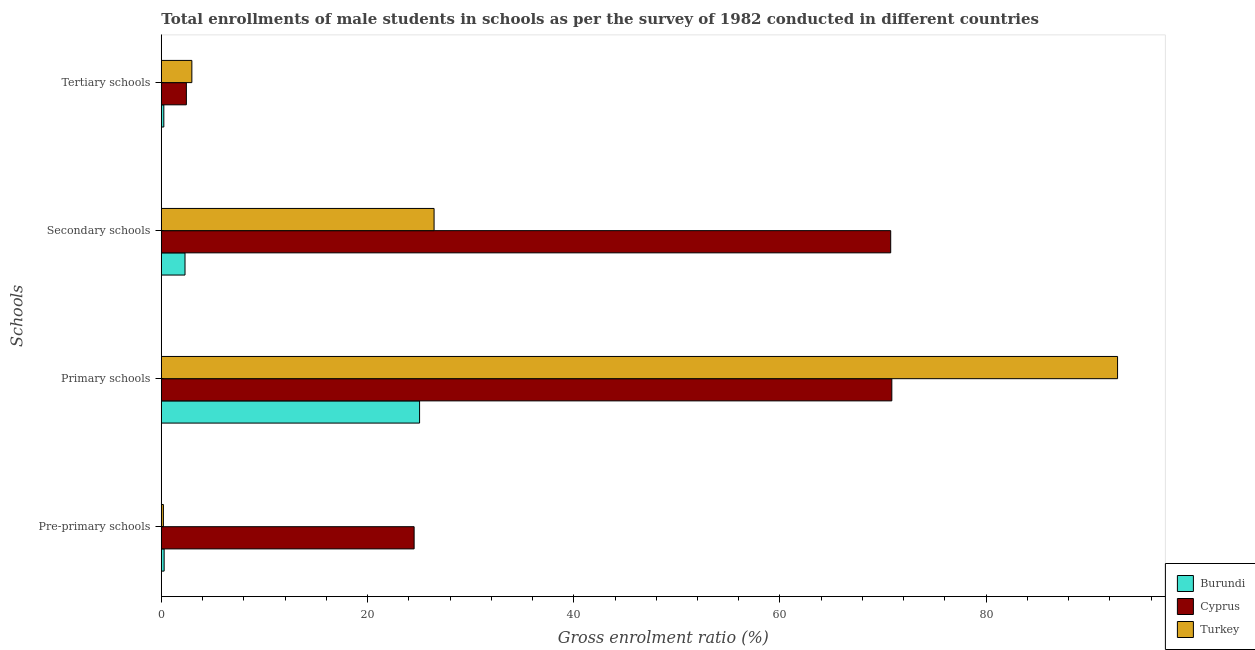Are the number of bars per tick equal to the number of legend labels?
Give a very brief answer. Yes. Are the number of bars on each tick of the Y-axis equal?
Provide a short and direct response. Yes. How many bars are there on the 1st tick from the top?
Ensure brevity in your answer.  3. What is the label of the 2nd group of bars from the top?
Your answer should be compact. Secondary schools. What is the gross enrolment ratio(male) in tertiary schools in Burundi?
Your answer should be very brief. 0.24. Across all countries, what is the maximum gross enrolment ratio(male) in primary schools?
Provide a succinct answer. 92.74. Across all countries, what is the minimum gross enrolment ratio(male) in primary schools?
Ensure brevity in your answer.  25.05. In which country was the gross enrolment ratio(male) in pre-primary schools minimum?
Offer a terse response. Turkey. What is the total gross enrolment ratio(male) in secondary schools in the graph?
Provide a short and direct response. 99.49. What is the difference between the gross enrolment ratio(male) in tertiary schools in Turkey and that in Cyprus?
Give a very brief answer. 0.53. What is the difference between the gross enrolment ratio(male) in tertiary schools in Cyprus and the gross enrolment ratio(male) in primary schools in Turkey?
Make the answer very short. -90.31. What is the average gross enrolment ratio(male) in primary schools per country?
Keep it short and to the point. 62.88. What is the difference between the gross enrolment ratio(male) in secondary schools and gross enrolment ratio(male) in tertiary schools in Cyprus?
Your answer should be compact. 68.31. What is the ratio of the gross enrolment ratio(male) in pre-primary schools in Turkey to that in Cyprus?
Keep it short and to the point. 0.01. Is the gross enrolment ratio(male) in secondary schools in Cyprus less than that in Burundi?
Give a very brief answer. No. What is the difference between the highest and the second highest gross enrolment ratio(male) in secondary schools?
Provide a succinct answer. 44.29. What is the difference between the highest and the lowest gross enrolment ratio(male) in secondary schools?
Provide a succinct answer. 68.44. In how many countries, is the gross enrolment ratio(male) in tertiary schools greater than the average gross enrolment ratio(male) in tertiary schools taken over all countries?
Make the answer very short. 2. Is the sum of the gross enrolment ratio(male) in primary schools in Turkey and Burundi greater than the maximum gross enrolment ratio(male) in tertiary schools across all countries?
Your answer should be compact. Yes. Is it the case that in every country, the sum of the gross enrolment ratio(male) in primary schools and gross enrolment ratio(male) in tertiary schools is greater than the sum of gross enrolment ratio(male) in pre-primary schools and gross enrolment ratio(male) in secondary schools?
Your answer should be very brief. Yes. What does the 3rd bar from the top in Tertiary schools represents?
Offer a terse response. Burundi. What does the 1st bar from the bottom in Tertiary schools represents?
Provide a short and direct response. Burundi. Is it the case that in every country, the sum of the gross enrolment ratio(male) in pre-primary schools and gross enrolment ratio(male) in primary schools is greater than the gross enrolment ratio(male) in secondary schools?
Offer a terse response. Yes. How many bars are there?
Your answer should be compact. 12. Are all the bars in the graph horizontal?
Keep it short and to the point. Yes. What is the difference between two consecutive major ticks on the X-axis?
Offer a terse response. 20. Does the graph contain any zero values?
Your answer should be compact. No. Does the graph contain grids?
Your response must be concise. No. Where does the legend appear in the graph?
Keep it short and to the point. Bottom right. How many legend labels are there?
Make the answer very short. 3. What is the title of the graph?
Provide a succinct answer. Total enrollments of male students in schools as per the survey of 1982 conducted in different countries. What is the label or title of the Y-axis?
Your answer should be very brief. Schools. What is the Gross enrolment ratio (%) in Burundi in Pre-primary schools?
Keep it short and to the point. 0.27. What is the Gross enrolment ratio (%) of Cyprus in Pre-primary schools?
Make the answer very short. 24.52. What is the Gross enrolment ratio (%) in Turkey in Pre-primary schools?
Your response must be concise. 0.2. What is the Gross enrolment ratio (%) of Burundi in Primary schools?
Your response must be concise. 25.05. What is the Gross enrolment ratio (%) in Cyprus in Primary schools?
Provide a short and direct response. 70.85. What is the Gross enrolment ratio (%) of Turkey in Primary schools?
Offer a terse response. 92.74. What is the Gross enrolment ratio (%) of Burundi in Secondary schools?
Ensure brevity in your answer.  2.3. What is the Gross enrolment ratio (%) of Cyprus in Secondary schools?
Your answer should be very brief. 70.74. What is the Gross enrolment ratio (%) of Turkey in Secondary schools?
Offer a terse response. 26.45. What is the Gross enrolment ratio (%) in Burundi in Tertiary schools?
Offer a very short reply. 0.24. What is the Gross enrolment ratio (%) of Cyprus in Tertiary schools?
Provide a succinct answer. 2.43. What is the Gross enrolment ratio (%) of Turkey in Tertiary schools?
Offer a very short reply. 2.96. Across all Schools, what is the maximum Gross enrolment ratio (%) of Burundi?
Your answer should be compact. 25.05. Across all Schools, what is the maximum Gross enrolment ratio (%) in Cyprus?
Your answer should be compact. 70.85. Across all Schools, what is the maximum Gross enrolment ratio (%) of Turkey?
Make the answer very short. 92.74. Across all Schools, what is the minimum Gross enrolment ratio (%) in Burundi?
Offer a terse response. 0.24. Across all Schools, what is the minimum Gross enrolment ratio (%) of Cyprus?
Keep it short and to the point. 2.43. Across all Schools, what is the minimum Gross enrolment ratio (%) of Turkey?
Keep it short and to the point. 0.2. What is the total Gross enrolment ratio (%) of Burundi in the graph?
Your answer should be very brief. 27.86. What is the total Gross enrolment ratio (%) in Cyprus in the graph?
Your answer should be very brief. 168.54. What is the total Gross enrolment ratio (%) in Turkey in the graph?
Provide a succinct answer. 122.36. What is the difference between the Gross enrolment ratio (%) in Burundi in Pre-primary schools and that in Primary schools?
Ensure brevity in your answer.  -24.77. What is the difference between the Gross enrolment ratio (%) in Cyprus in Pre-primary schools and that in Primary schools?
Give a very brief answer. -46.33. What is the difference between the Gross enrolment ratio (%) in Turkey in Pre-primary schools and that in Primary schools?
Your answer should be very brief. -92.54. What is the difference between the Gross enrolment ratio (%) in Burundi in Pre-primary schools and that in Secondary schools?
Your answer should be very brief. -2.02. What is the difference between the Gross enrolment ratio (%) of Cyprus in Pre-primary schools and that in Secondary schools?
Keep it short and to the point. -46.22. What is the difference between the Gross enrolment ratio (%) in Turkey in Pre-primary schools and that in Secondary schools?
Offer a very short reply. -26.25. What is the difference between the Gross enrolment ratio (%) of Burundi in Pre-primary schools and that in Tertiary schools?
Offer a terse response. 0.03. What is the difference between the Gross enrolment ratio (%) of Cyprus in Pre-primary schools and that in Tertiary schools?
Give a very brief answer. 22.09. What is the difference between the Gross enrolment ratio (%) of Turkey in Pre-primary schools and that in Tertiary schools?
Make the answer very short. -2.76. What is the difference between the Gross enrolment ratio (%) of Burundi in Primary schools and that in Secondary schools?
Make the answer very short. 22.75. What is the difference between the Gross enrolment ratio (%) of Cyprus in Primary schools and that in Secondary schools?
Your answer should be very brief. 0.11. What is the difference between the Gross enrolment ratio (%) of Turkey in Primary schools and that in Secondary schools?
Provide a succinct answer. 66.29. What is the difference between the Gross enrolment ratio (%) in Burundi in Primary schools and that in Tertiary schools?
Make the answer very short. 24.8. What is the difference between the Gross enrolment ratio (%) of Cyprus in Primary schools and that in Tertiary schools?
Provide a short and direct response. 68.42. What is the difference between the Gross enrolment ratio (%) in Turkey in Primary schools and that in Tertiary schools?
Your answer should be compact. 89.78. What is the difference between the Gross enrolment ratio (%) in Burundi in Secondary schools and that in Tertiary schools?
Provide a short and direct response. 2.05. What is the difference between the Gross enrolment ratio (%) of Cyprus in Secondary schools and that in Tertiary schools?
Provide a succinct answer. 68.31. What is the difference between the Gross enrolment ratio (%) of Turkey in Secondary schools and that in Tertiary schools?
Provide a short and direct response. 23.49. What is the difference between the Gross enrolment ratio (%) of Burundi in Pre-primary schools and the Gross enrolment ratio (%) of Cyprus in Primary schools?
Ensure brevity in your answer.  -70.58. What is the difference between the Gross enrolment ratio (%) of Burundi in Pre-primary schools and the Gross enrolment ratio (%) of Turkey in Primary schools?
Offer a terse response. -92.47. What is the difference between the Gross enrolment ratio (%) of Cyprus in Pre-primary schools and the Gross enrolment ratio (%) of Turkey in Primary schools?
Offer a very short reply. -68.22. What is the difference between the Gross enrolment ratio (%) of Burundi in Pre-primary schools and the Gross enrolment ratio (%) of Cyprus in Secondary schools?
Give a very brief answer. -70.47. What is the difference between the Gross enrolment ratio (%) of Burundi in Pre-primary schools and the Gross enrolment ratio (%) of Turkey in Secondary schools?
Your answer should be compact. -26.18. What is the difference between the Gross enrolment ratio (%) in Cyprus in Pre-primary schools and the Gross enrolment ratio (%) in Turkey in Secondary schools?
Make the answer very short. -1.94. What is the difference between the Gross enrolment ratio (%) of Burundi in Pre-primary schools and the Gross enrolment ratio (%) of Cyprus in Tertiary schools?
Your answer should be very brief. -2.16. What is the difference between the Gross enrolment ratio (%) in Burundi in Pre-primary schools and the Gross enrolment ratio (%) in Turkey in Tertiary schools?
Provide a succinct answer. -2.69. What is the difference between the Gross enrolment ratio (%) of Cyprus in Pre-primary schools and the Gross enrolment ratio (%) of Turkey in Tertiary schools?
Your answer should be compact. 21.56. What is the difference between the Gross enrolment ratio (%) in Burundi in Primary schools and the Gross enrolment ratio (%) in Cyprus in Secondary schools?
Your response must be concise. -45.69. What is the difference between the Gross enrolment ratio (%) in Burundi in Primary schools and the Gross enrolment ratio (%) in Turkey in Secondary schools?
Offer a very short reply. -1.41. What is the difference between the Gross enrolment ratio (%) in Cyprus in Primary schools and the Gross enrolment ratio (%) in Turkey in Secondary schools?
Keep it short and to the point. 44.4. What is the difference between the Gross enrolment ratio (%) of Burundi in Primary schools and the Gross enrolment ratio (%) of Cyprus in Tertiary schools?
Your response must be concise. 22.62. What is the difference between the Gross enrolment ratio (%) of Burundi in Primary schools and the Gross enrolment ratio (%) of Turkey in Tertiary schools?
Provide a succinct answer. 22.08. What is the difference between the Gross enrolment ratio (%) in Cyprus in Primary schools and the Gross enrolment ratio (%) in Turkey in Tertiary schools?
Provide a short and direct response. 67.89. What is the difference between the Gross enrolment ratio (%) of Burundi in Secondary schools and the Gross enrolment ratio (%) of Cyprus in Tertiary schools?
Your response must be concise. -0.13. What is the difference between the Gross enrolment ratio (%) of Burundi in Secondary schools and the Gross enrolment ratio (%) of Turkey in Tertiary schools?
Provide a short and direct response. -0.66. What is the difference between the Gross enrolment ratio (%) of Cyprus in Secondary schools and the Gross enrolment ratio (%) of Turkey in Tertiary schools?
Make the answer very short. 67.78. What is the average Gross enrolment ratio (%) of Burundi per Schools?
Provide a succinct answer. 6.97. What is the average Gross enrolment ratio (%) in Cyprus per Schools?
Give a very brief answer. 42.13. What is the average Gross enrolment ratio (%) of Turkey per Schools?
Provide a short and direct response. 30.59. What is the difference between the Gross enrolment ratio (%) in Burundi and Gross enrolment ratio (%) in Cyprus in Pre-primary schools?
Ensure brevity in your answer.  -24.24. What is the difference between the Gross enrolment ratio (%) of Burundi and Gross enrolment ratio (%) of Turkey in Pre-primary schools?
Your response must be concise. 0.07. What is the difference between the Gross enrolment ratio (%) of Cyprus and Gross enrolment ratio (%) of Turkey in Pre-primary schools?
Keep it short and to the point. 24.32. What is the difference between the Gross enrolment ratio (%) in Burundi and Gross enrolment ratio (%) in Cyprus in Primary schools?
Provide a short and direct response. -45.8. What is the difference between the Gross enrolment ratio (%) in Burundi and Gross enrolment ratio (%) in Turkey in Primary schools?
Provide a succinct answer. -67.7. What is the difference between the Gross enrolment ratio (%) of Cyprus and Gross enrolment ratio (%) of Turkey in Primary schools?
Ensure brevity in your answer.  -21.89. What is the difference between the Gross enrolment ratio (%) of Burundi and Gross enrolment ratio (%) of Cyprus in Secondary schools?
Your response must be concise. -68.44. What is the difference between the Gross enrolment ratio (%) of Burundi and Gross enrolment ratio (%) of Turkey in Secondary schools?
Make the answer very short. -24.16. What is the difference between the Gross enrolment ratio (%) of Cyprus and Gross enrolment ratio (%) of Turkey in Secondary schools?
Ensure brevity in your answer.  44.29. What is the difference between the Gross enrolment ratio (%) of Burundi and Gross enrolment ratio (%) of Cyprus in Tertiary schools?
Give a very brief answer. -2.19. What is the difference between the Gross enrolment ratio (%) of Burundi and Gross enrolment ratio (%) of Turkey in Tertiary schools?
Offer a terse response. -2.72. What is the difference between the Gross enrolment ratio (%) of Cyprus and Gross enrolment ratio (%) of Turkey in Tertiary schools?
Offer a very short reply. -0.53. What is the ratio of the Gross enrolment ratio (%) of Burundi in Pre-primary schools to that in Primary schools?
Keep it short and to the point. 0.01. What is the ratio of the Gross enrolment ratio (%) of Cyprus in Pre-primary schools to that in Primary schools?
Your response must be concise. 0.35. What is the ratio of the Gross enrolment ratio (%) in Turkey in Pre-primary schools to that in Primary schools?
Provide a succinct answer. 0. What is the ratio of the Gross enrolment ratio (%) in Burundi in Pre-primary schools to that in Secondary schools?
Offer a very short reply. 0.12. What is the ratio of the Gross enrolment ratio (%) of Cyprus in Pre-primary schools to that in Secondary schools?
Provide a short and direct response. 0.35. What is the ratio of the Gross enrolment ratio (%) of Turkey in Pre-primary schools to that in Secondary schools?
Your answer should be very brief. 0.01. What is the ratio of the Gross enrolment ratio (%) in Burundi in Pre-primary schools to that in Tertiary schools?
Provide a short and direct response. 1.12. What is the ratio of the Gross enrolment ratio (%) of Cyprus in Pre-primary schools to that in Tertiary schools?
Make the answer very short. 10.09. What is the ratio of the Gross enrolment ratio (%) of Turkey in Pre-primary schools to that in Tertiary schools?
Your response must be concise. 0.07. What is the ratio of the Gross enrolment ratio (%) of Burundi in Primary schools to that in Secondary schools?
Provide a short and direct response. 10.9. What is the ratio of the Gross enrolment ratio (%) of Cyprus in Primary schools to that in Secondary schools?
Keep it short and to the point. 1. What is the ratio of the Gross enrolment ratio (%) of Turkey in Primary schools to that in Secondary schools?
Provide a short and direct response. 3.51. What is the ratio of the Gross enrolment ratio (%) of Burundi in Primary schools to that in Tertiary schools?
Make the answer very short. 102.85. What is the ratio of the Gross enrolment ratio (%) of Cyprus in Primary schools to that in Tertiary schools?
Give a very brief answer. 29.16. What is the ratio of the Gross enrolment ratio (%) of Turkey in Primary schools to that in Tertiary schools?
Ensure brevity in your answer.  31.3. What is the ratio of the Gross enrolment ratio (%) of Burundi in Secondary schools to that in Tertiary schools?
Make the answer very short. 9.44. What is the ratio of the Gross enrolment ratio (%) of Cyprus in Secondary schools to that in Tertiary schools?
Your answer should be compact. 29.11. What is the ratio of the Gross enrolment ratio (%) of Turkey in Secondary schools to that in Tertiary schools?
Your response must be concise. 8.93. What is the difference between the highest and the second highest Gross enrolment ratio (%) in Burundi?
Your answer should be very brief. 22.75. What is the difference between the highest and the second highest Gross enrolment ratio (%) of Cyprus?
Make the answer very short. 0.11. What is the difference between the highest and the second highest Gross enrolment ratio (%) of Turkey?
Provide a succinct answer. 66.29. What is the difference between the highest and the lowest Gross enrolment ratio (%) of Burundi?
Make the answer very short. 24.8. What is the difference between the highest and the lowest Gross enrolment ratio (%) of Cyprus?
Your answer should be very brief. 68.42. What is the difference between the highest and the lowest Gross enrolment ratio (%) of Turkey?
Your answer should be very brief. 92.54. 